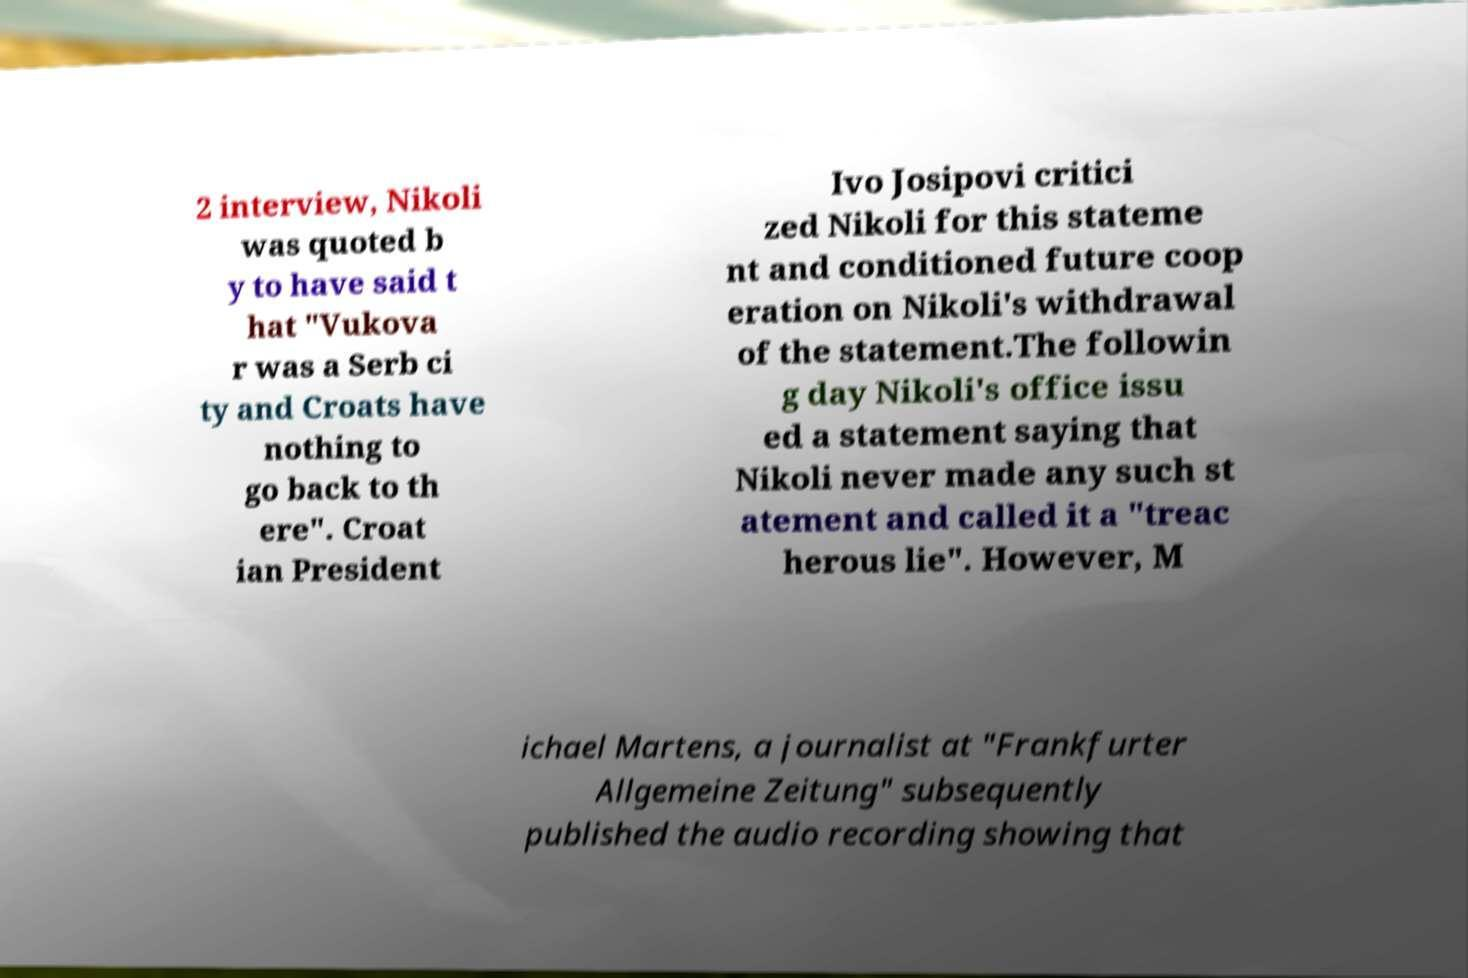Can you accurately transcribe the text from the provided image for me? 2 interview, Nikoli was quoted b y to have said t hat ″Vukova r was a Serb ci ty and Croats have nothing to go back to th ere″. Croat ian President Ivo Josipovi critici zed Nikoli for this stateme nt and conditioned future coop eration on Nikoli's withdrawal of the statement.The followin g day Nikoli's office issu ed a statement saying that Nikoli never made any such st atement and called it a ″treac herous lie″. However, M ichael Martens, a journalist at "Frankfurter Allgemeine Zeitung" subsequently published the audio recording showing that 